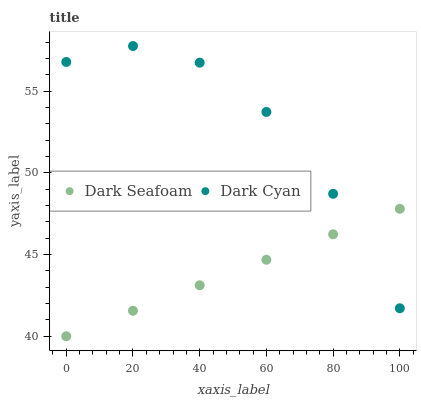Does Dark Seafoam have the minimum area under the curve?
Answer yes or no. Yes. Does Dark Cyan have the maximum area under the curve?
Answer yes or no. Yes. Does Dark Seafoam have the maximum area under the curve?
Answer yes or no. No. Is Dark Seafoam the smoothest?
Answer yes or no. Yes. Is Dark Cyan the roughest?
Answer yes or no. Yes. Is Dark Seafoam the roughest?
Answer yes or no. No. Does Dark Seafoam have the lowest value?
Answer yes or no. Yes. Does Dark Cyan have the highest value?
Answer yes or no. Yes. Does Dark Seafoam have the highest value?
Answer yes or no. No. Does Dark Cyan intersect Dark Seafoam?
Answer yes or no. Yes. Is Dark Cyan less than Dark Seafoam?
Answer yes or no. No. Is Dark Cyan greater than Dark Seafoam?
Answer yes or no. No. 